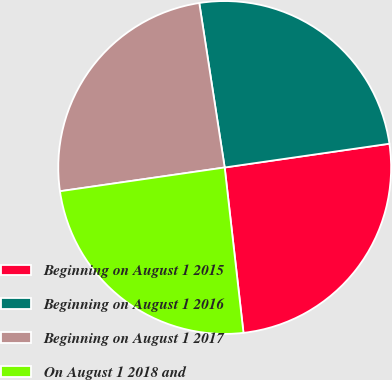Convert chart to OTSL. <chart><loc_0><loc_0><loc_500><loc_500><pie_chart><fcel>Beginning on August 1 2015<fcel>Beginning on August 1 2016<fcel>Beginning on August 1 2017<fcel>On August 1 2018 and<nl><fcel>25.48%<fcel>25.16%<fcel>24.84%<fcel>24.52%<nl></chart> 